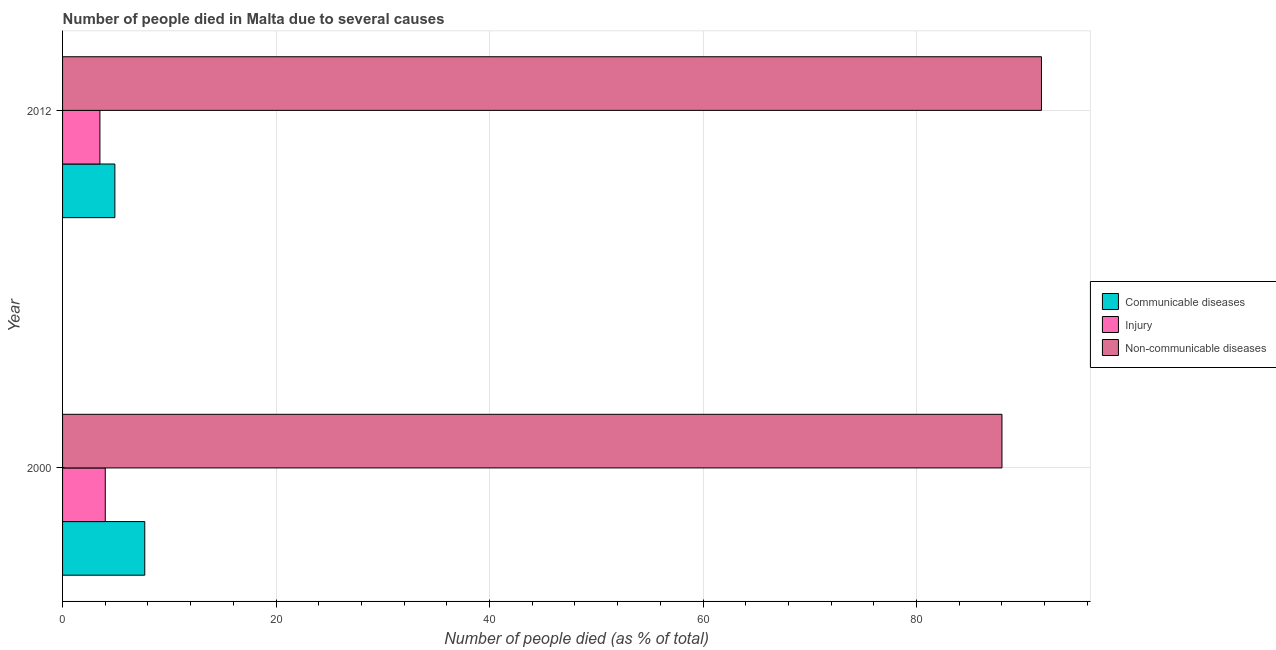How many different coloured bars are there?
Offer a terse response. 3. How many groups of bars are there?
Provide a short and direct response. 2. Are the number of bars on each tick of the Y-axis equal?
Provide a succinct answer. Yes. How many bars are there on the 2nd tick from the top?
Offer a very short reply. 3. How many bars are there on the 2nd tick from the bottom?
Make the answer very short. 3. What is the label of the 2nd group of bars from the top?
Give a very brief answer. 2000. What is the number of people who died of communicable diseases in 2012?
Your answer should be compact. 4.9. Across all years, what is the maximum number of people who dies of non-communicable diseases?
Your answer should be very brief. 91.7. Across all years, what is the minimum number of people who dies of non-communicable diseases?
Give a very brief answer. 88. In which year was the number of people who dies of non-communicable diseases maximum?
Offer a terse response. 2012. What is the total number of people who died of communicable diseases in the graph?
Offer a terse response. 12.6. What is the difference between the number of people who died of communicable diseases in 2000 and that in 2012?
Your response must be concise. 2.8. What is the difference between the number of people who died of communicable diseases in 2000 and the number of people who dies of non-communicable diseases in 2012?
Offer a very short reply. -84. What is the average number of people who died of injury per year?
Offer a very short reply. 3.75. What is the ratio of the number of people who died of communicable diseases in 2000 to that in 2012?
Keep it short and to the point. 1.57. Is the difference between the number of people who dies of non-communicable diseases in 2000 and 2012 greater than the difference between the number of people who died of injury in 2000 and 2012?
Your answer should be compact. No. What does the 2nd bar from the top in 2012 represents?
Your answer should be compact. Injury. What does the 3rd bar from the bottom in 2012 represents?
Your answer should be compact. Non-communicable diseases. Is it the case that in every year, the sum of the number of people who died of communicable diseases and number of people who died of injury is greater than the number of people who dies of non-communicable diseases?
Your answer should be compact. No. Are all the bars in the graph horizontal?
Give a very brief answer. Yes. How many years are there in the graph?
Your answer should be compact. 2. What is the difference between two consecutive major ticks on the X-axis?
Keep it short and to the point. 20. Does the graph contain grids?
Your answer should be compact. Yes. Where does the legend appear in the graph?
Keep it short and to the point. Center right. What is the title of the graph?
Offer a very short reply. Number of people died in Malta due to several causes. Does "New Zealand" appear as one of the legend labels in the graph?
Offer a terse response. No. What is the label or title of the X-axis?
Give a very brief answer. Number of people died (as % of total). What is the label or title of the Y-axis?
Provide a short and direct response. Year. What is the Number of people died (as % of total) in Injury in 2000?
Provide a succinct answer. 4. What is the Number of people died (as % of total) of Injury in 2012?
Offer a very short reply. 3.5. What is the Number of people died (as % of total) of Non-communicable diseases in 2012?
Your answer should be very brief. 91.7. Across all years, what is the maximum Number of people died (as % of total) in Non-communicable diseases?
Your response must be concise. 91.7. Across all years, what is the minimum Number of people died (as % of total) of Communicable diseases?
Provide a short and direct response. 4.9. Across all years, what is the minimum Number of people died (as % of total) of Non-communicable diseases?
Provide a succinct answer. 88. What is the total Number of people died (as % of total) of Non-communicable diseases in the graph?
Provide a short and direct response. 179.7. What is the difference between the Number of people died (as % of total) of Injury in 2000 and that in 2012?
Your answer should be very brief. 0.5. What is the difference between the Number of people died (as % of total) in Non-communicable diseases in 2000 and that in 2012?
Make the answer very short. -3.7. What is the difference between the Number of people died (as % of total) in Communicable diseases in 2000 and the Number of people died (as % of total) in Non-communicable diseases in 2012?
Make the answer very short. -84. What is the difference between the Number of people died (as % of total) in Injury in 2000 and the Number of people died (as % of total) in Non-communicable diseases in 2012?
Provide a succinct answer. -87.7. What is the average Number of people died (as % of total) in Injury per year?
Make the answer very short. 3.75. What is the average Number of people died (as % of total) in Non-communicable diseases per year?
Offer a very short reply. 89.85. In the year 2000, what is the difference between the Number of people died (as % of total) in Communicable diseases and Number of people died (as % of total) in Injury?
Provide a succinct answer. 3.7. In the year 2000, what is the difference between the Number of people died (as % of total) in Communicable diseases and Number of people died (as % of total) in Non-communicable diseases?
Give a very brief answer. -80.3. In the year 2000, what is the difference between the Number of people died (as % of total) of Injury and Number of people died (as % of total) of Non-communicable diseases?
Your response must be concise. -84. In the year 2012, what is the difference between the Number of people died (as % of total) of Communicable diseases and Number of people died (as % of total) of Injury?
Ensure brevity in your answer.  1.4. In the year 2012, what is the difference between the Number of people died (as % of total) in Communicable diseases and Number of people died (as % of total) in Non-communicable diseases?
Keep it short and to the point. -86.8. In the year 2012, what is the difference between the Number of people died (as % of total) in Injury and Number of people died (as % of total) in Non-communicable diseases?
Offer a terse response. -88.2. What is the ratio of the Number of people died (as % of total) in Communicable diseases in 2000 to that in 2012?
Your answer should be very brief. 1.57. What is the ratio of the Number of people died (as % of total) of Injury in 2000 to that in 2012?
Provide a succinct answer. 1.14. What is the ratio of the Number of people died (as % of total) in Non-communicable diseases in 2000 to that in 2012?
Your answer should be very brief. 0.96. What is the difference between the highest and the second highest Number of people died (as % of total) of Communicable diseases?
Provide a short and direct response. 2.8. What is the difference between the highest and the second highest Number of people died (as % of total) of Injury?
Ensure brevity in your answer.  0.5. What is the difference between the highest and the lowest Number of people died (as % of total) in Non-communicable diseases?
Ensure brevity in your answer.  3.7. 